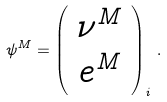<formula> <loc_0><loc_0><loc_500><loc_500>\psi ^ { M } = \left ( \begin{array} { c } \nu ^ { M } \\ e ^ { M } \end{array} \right ) _ { i } \, .</formula> 